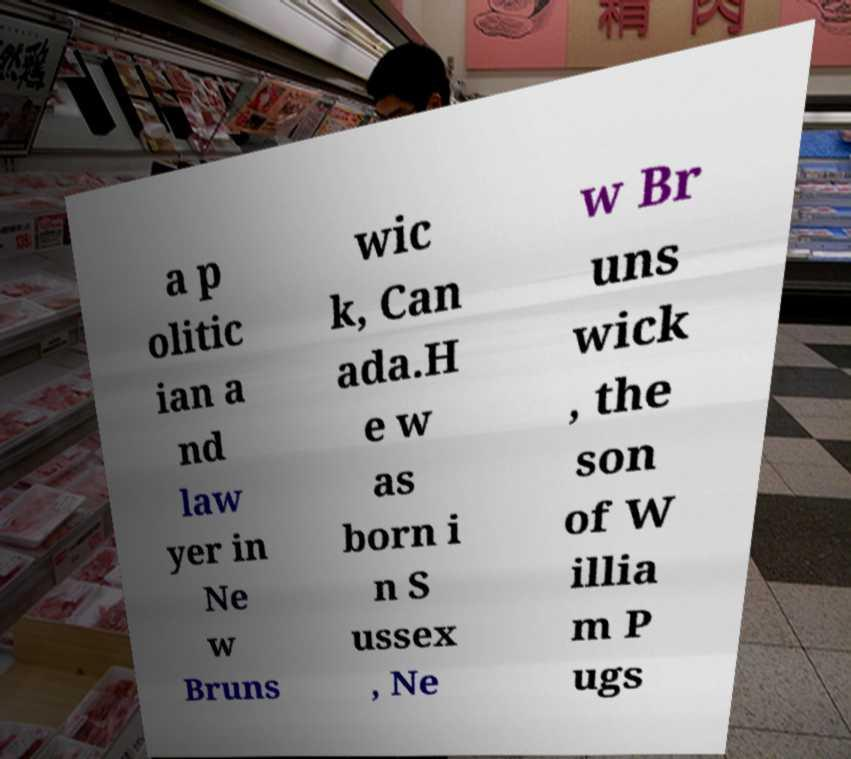Could you assist in decoding the text presented in this image and type it out clearly? a p olitic ian a nd law yer in Ne w Bruns wic k, Can ada.H e w as born i n S ussex , Ne w Br uns wick , the son of W illia m P ugs 